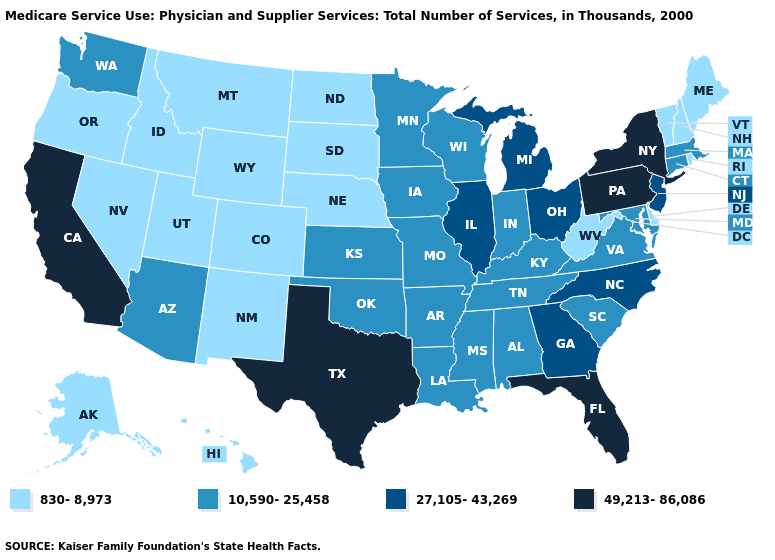Does the first symbol in the legend represent the smallest category?
Keep it brief. Yes. Does Connecticut have the highest value in the Northeast?
Give a very brief answer. No. Does Pennsylvania have a lower value than Hawaii?
Be succinct. No. What is the value of Delaware?
Answer briefly. 830-8,973. Name the states that have a value in the range 49,213-86,086?
Concise answer only. California, Florida, New York, Pennsylvania, Texas. What is the value of Ohio?
Be succinct. 27,105-43,269. Name the states that have a value in the range 830-8,973?
Give a very brief answer. Alaska, Colorado, Delaware, Hawaii, Idaho, Maine, Montana, Nebraska, Nevada, New Hampshire, New Mexico, North Dakota, Oregon, Rhode Island, South Dakota, Utah, Vermont, West Virginia, Wyoming. What is the highest value in the USA?
Give a very brief answer. 49,213-86,086. Among the states that border Iowa , does Minnesota have the lowest value?
Give a very brief answer. No. Name the states that have a value in the range 27,105-43,269?
Short answer required. Georgia, Illinois, Michigan, New Jersey, North Carolina, Ohio. What is the lowest value in the South?
Answer briefly. 830-8,973. What is the value of Kansas?
Write a very short answer. 10,590-25,458. What is the value of Oregon?
Keep it brief. 830-8,973. Name the states that have a value in the range 27,105-43,269?
Short answer required. Georgia, Illinois, Michigan, New Jersey, North Carolina, Ohio. Name the states that have a value in the range 10,590-25,458?
Be succinct. Alabama, Arizona, Arkansas, Connecticut, Indiana, Iowa, Kansas, Kentucky, Louisiana, Maryland, Massachusetts, Minnesota, Mississippi, Missouri, Oklahoma, South Carolina, Tennessee, Virginia, Washington, Wisconsin. 